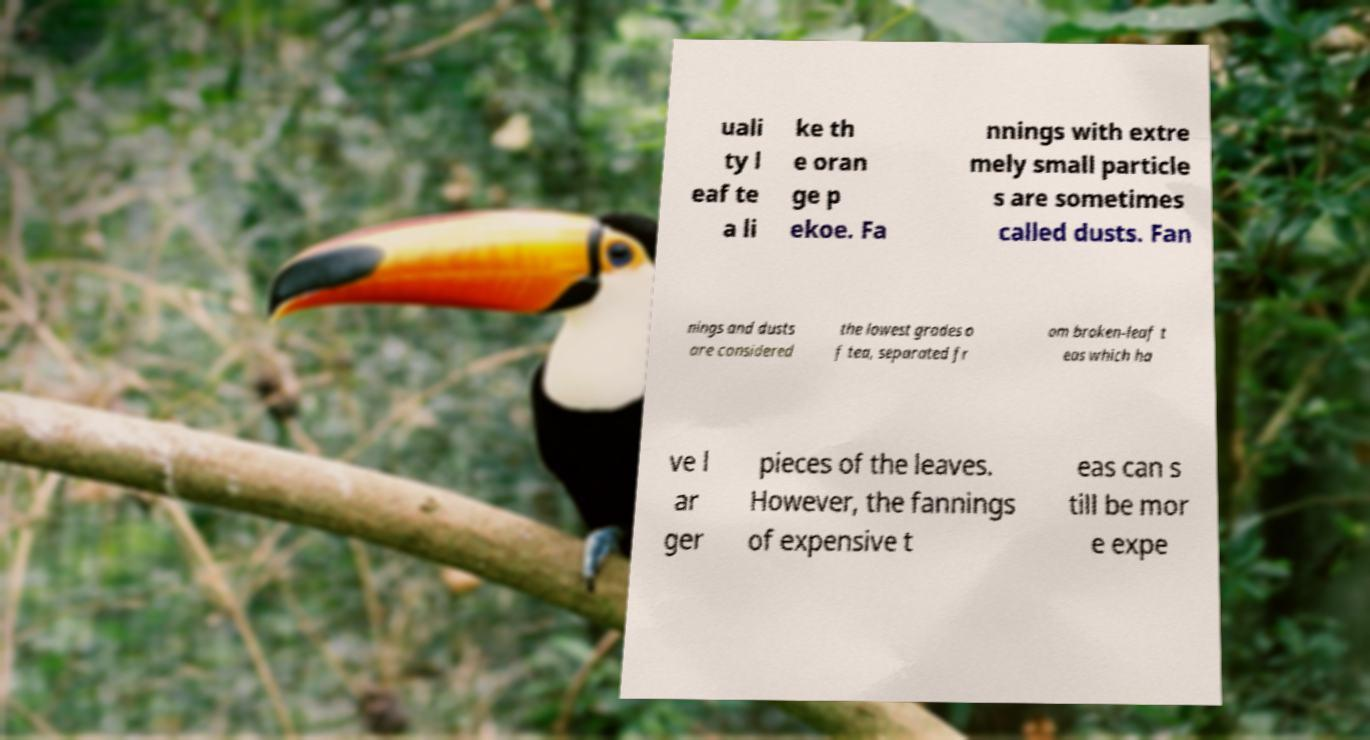Could you extract and type out the text from this image? uali ty l eaf te a li ke th e oran ge p ekoe. Fa nnings with extre mely small particle s are sometimes called dusts. Fan nings and dusts are considered the lowest grades o f tea, separated fr om broken-leaf t eas which ha ve l ar ger pieces of the leaves. However, the fannings of expensive t eas can s till be mor e expe 